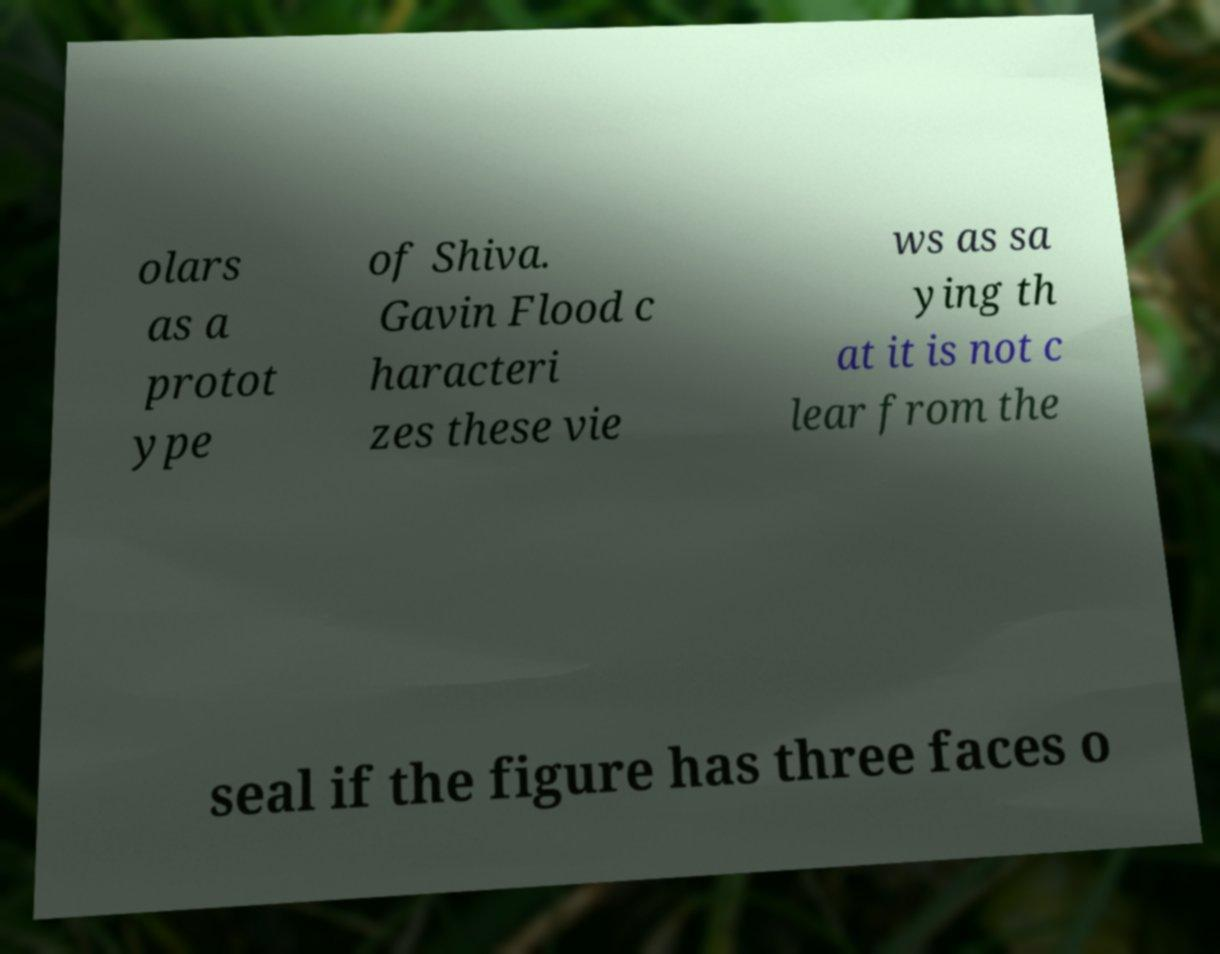Can you read and provide the text displayed in the image?This photo seems to have some interesting text. Can you extract and type it out for me? olars as a protot ype of Shiva. Gavin Flood c haracteri zes these vie ws as sa ying th at it is not c lear from the seal if the figure has three faces o 